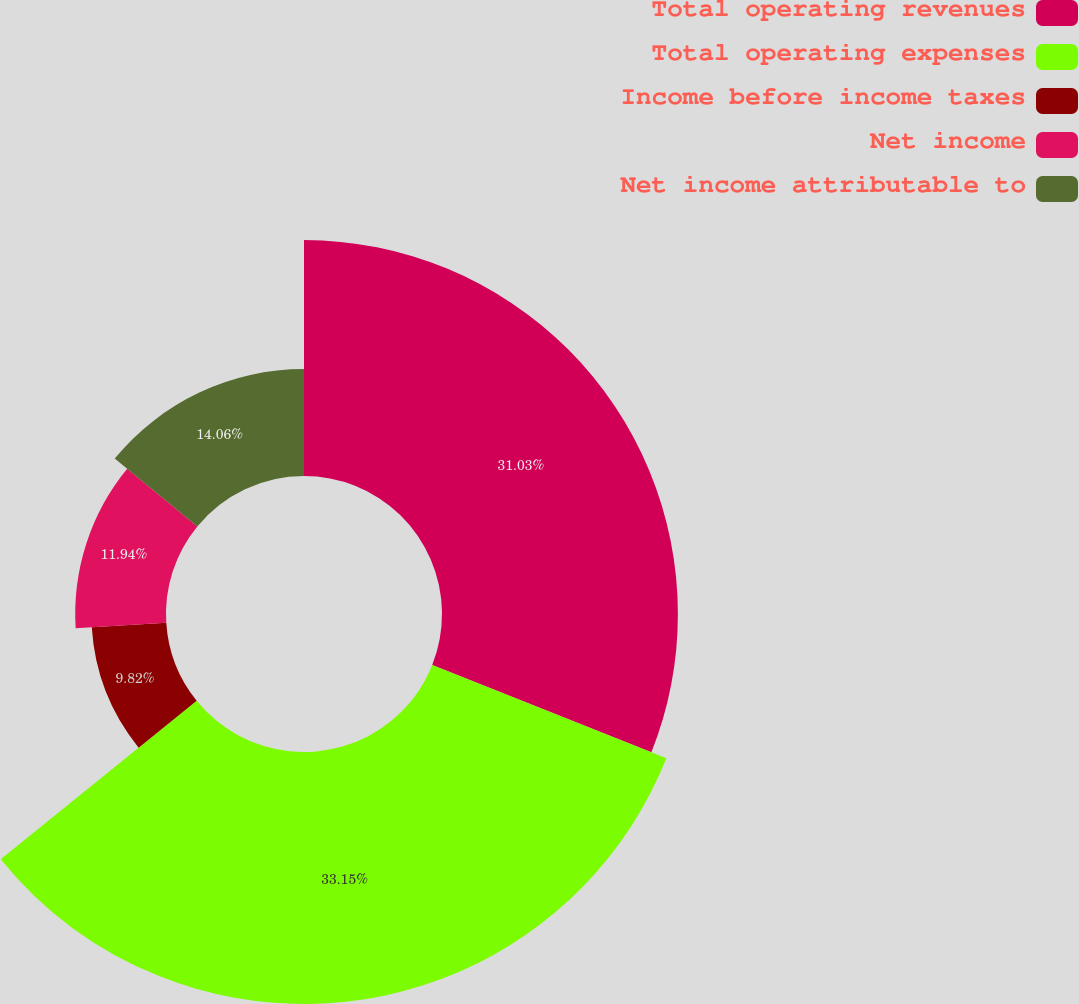<chart> <loc_0><loc_0><loc_500><loc_500><pie_chart><fcel>Total operating revenues<fcel>Total operating expenses<fcel>Income before income taxes<fcel>Net income<fcel>Net income attributable to<nl><fcel>31.03%<fcel>33.15%<fcel>9.82%<fcel>11.94%<fcel>14.06%<nl></chart> 